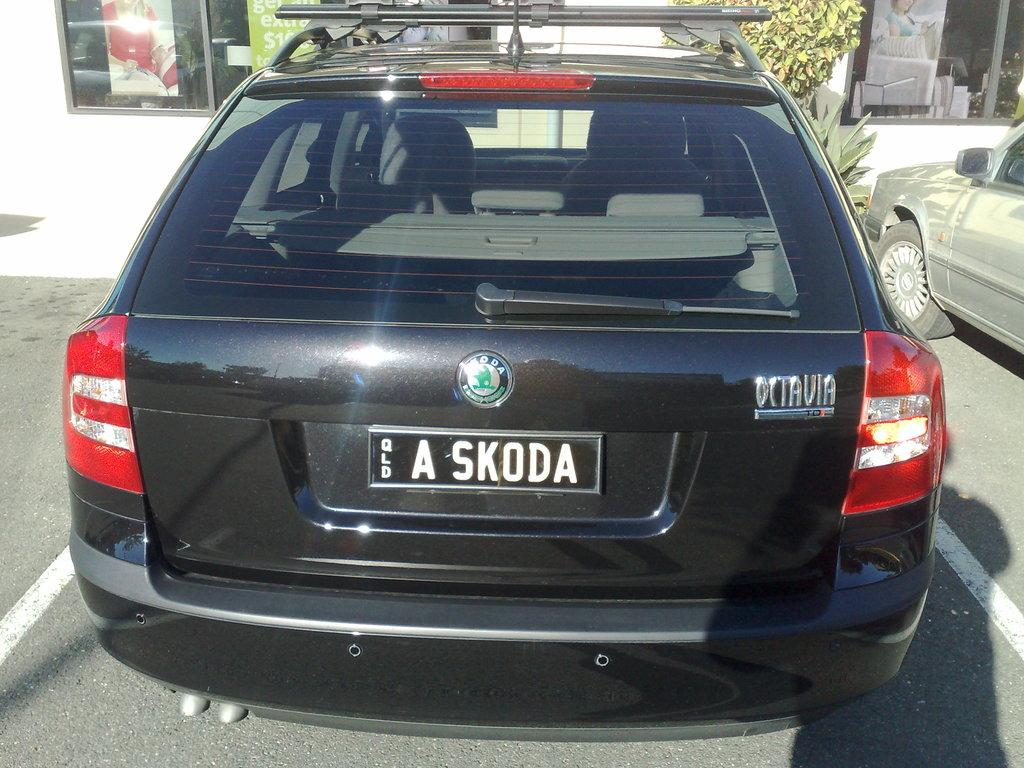<image>
Describe the image concisely. Black car with a plate which says ASKODA> 